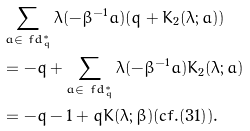Convert formula to latex. <formula><loc_0><loc_0><loc_500><loc_500>& \sum _ { a \in \ f d _ { q } ^ { * } } \lambda ( - \beta ^ { - 1 } a ) ( q + K _ { 2 } ( \lambda ; a ) ) \\ & = - q + \sum _ { a \in \ f d _ { q } ^ { * } } \lambda ( - \beta ^ { - 1 } a ) K _ { 2 } ( \lambda ; a ) \\ & = - q - 1 + q K ( \lambda ; \beta ) ( c f . ( 3 1 ) ) .</formula> 